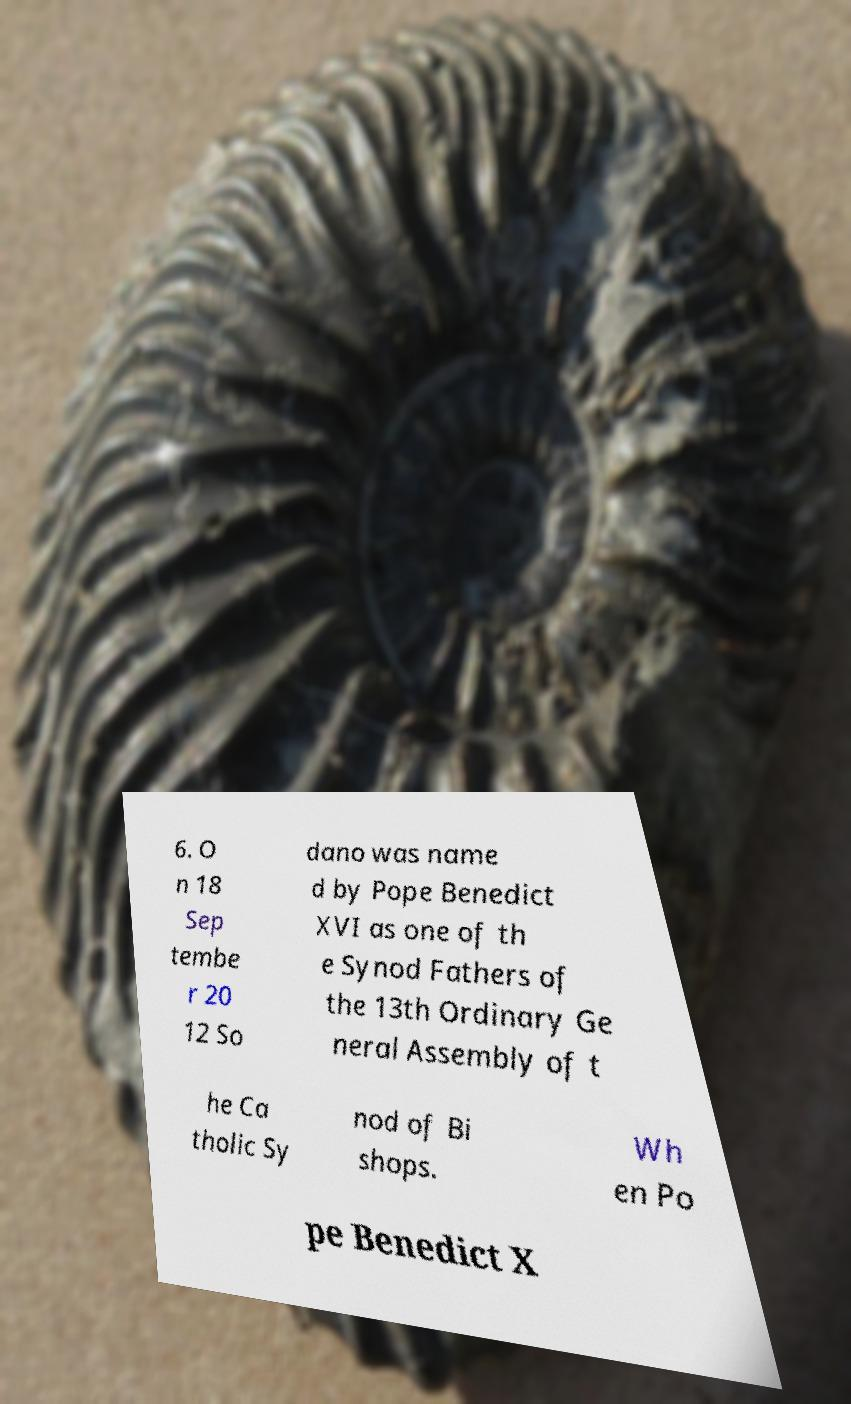Please identify and transcribe the text found in this image. 6. O n 18 Sep tembe r 20 12 So dano was name d by Pope Benedict XVI as one of th e Synod Fathers of the 13th Ordinary Ge neral Assembly of t he Ca tholic Sy nod of Bi shops. Wh en Po pe Benedict X 